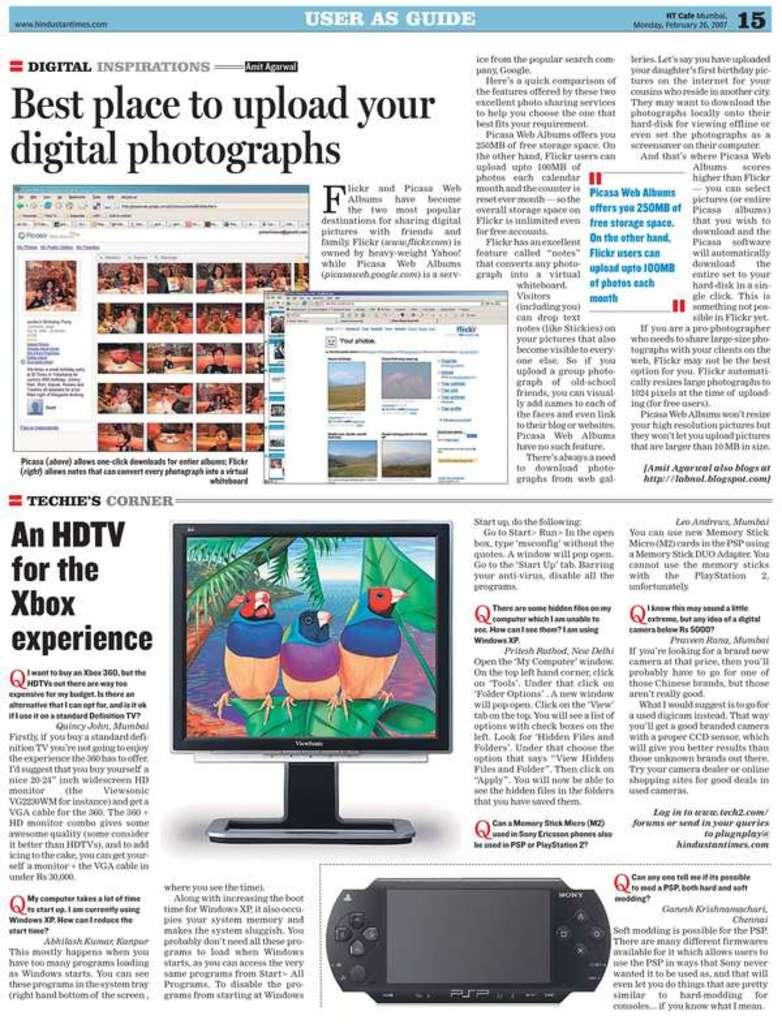Provide a one-sentence caption for the provided image. A page of a magazine with information on digital issues. 